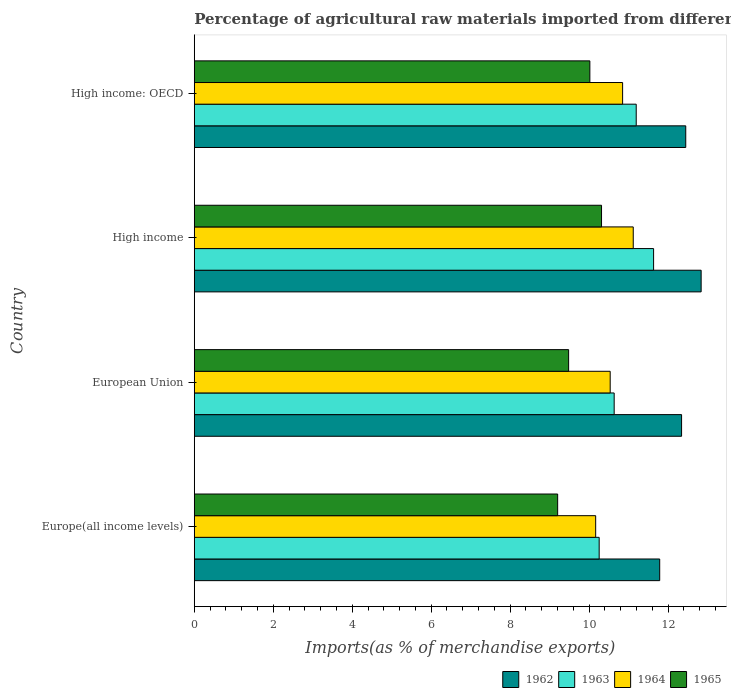How many groups of bars are there?
Provide a succinct answer. 4. Are the number of bars per tick equal to the number of legend labels?
Give a very brief answer. Yes. How many bars are there on the 3rd tick from the top?
Offer a terse response. 4. How many bars are there on the 4th tick from the bottom?
Provide a succinct answer. 4. What is the label of the 4th group of bars from the top?
Provide a succinct answer. Europe(all income levels). In how many cases, is the number of bars for a given country not equal to the number of legend labels?
Provide a succinct answer. 0. What is the percentage of imports to different countries in 1962 in High income?
Offer a terse response. 12.84. Across all countries, what is the maximum percentage of imports to different countries in 1962?
Ensure brevity in your answer.  12.84. Across all countries, what is the minimum percentage of imports to different countries in 1965?
Give a very brief answer. 9.2. In which country was the percentage of imports to different countries in 1964 minimum?
Ensure brevity in your answer.  Europe(all income levels). What is the total percentage of imports to different countries in 1964 in the graph?
Your answer should be very brief. 42.66. What is the difference between the percentage of imports to different countries in 1962 in European Union and that in High income: OECD?
Your answer should be very brief. -0.11. What is the difference between the percentage of imports to different countries in 1965 in High income and the percentage of imports to different countries in 1963 in High income: OECD?
Ensure brevity in your answer.  -0.88. What is the average percentage of imports to different countries in 1963 per country?
Ensure brevity in your answer.  10.93. What is the difference between the percentage of imports to different countries in 1964 and percentage of imports to different countries in 1963 in High income?
Make the answer very short. -0.52. What is the ratio of the percentage of imports to different countries in 1963 in High income to that in High income: OECD?
Keep it short and to the point. 1.04. Is the percentage of imports to different countries in 1963 in European Union less than that in High income: OECD?
Keep it short and to the point. Yes. Is the difference between the percentage of imports to different countries in 1964 in European Union and High income: OECD greater than the difference between the percentage of imports to different countries in 1963 in European Union and High income: OECD?
Your response must be concise. Yes. What is the difference between the highest and the second highest percentage of imports to different countries in 1962?
Provide a succinct answer. 0.39. What is the difference between the highest and the lowest percentage of imports to different countries in 1963?
Make the answer very short. 1.38. In how many countries, is the percentage of imports to different countries in 1965 greater than the average percentage of imports to different countries in 1965 taken over all countries?
Provide a short and direct response. 2. Is the sum of the percentage of imports to different countries in 1965 in European Union and High income: OECD greater than the maximum percentage of imports to different countries in 1962 across all countries?
Your response must be concise. Yes. What does the 3rd bar from the top in High income represents?
Ensure brevity in your answer.  1963. Is it the case that in every country, the sum of the percentage of imports to different countries in 1962 and percentage of imports to different countries in 1963 is greater than the percentage of imports to different countries in 1964?
Provide a short and direct response. Yes. Does the graph contain any zero values?
Your answer should be very brief. No. Does the graph contain grids?
Offer a very short reply. No. How many legend labels are there?
Offer a terse response. 4. What is the title of the graph?
Keep it short and to the point. Percentage of agricultural raw materials imported from different countries. What is the label or title of the X-axis?
Ensure brevity in your answer.  Imports(as % of merchandise exports). What is the label or title of the Y-axis?
Your response must be concise. Country. What is the Imports(as % of merchandise exports) of 1962 in Europe(all income levels)?
Your answer should be compact. 11.79. What is the Imports(as % of merchandise exports) of 1963 in Europe(all income levels)?
Your response must be concise. 10.25. What is the Imports(as % of merchandise exports) of 1964 in Europe(all income levels)?
Keep it short and to the point. 10.17. What is the Imports(as % of merchandise exports) in 1965 in Europe(all income levels)?
Make the answer very short. 9.2. What is the Imports(as % of merchandise exports) of 1962 in European Union?
Keep it short and to the point. 12.34. What is the Imports(as % of merchandise exports) in 1963 in European Union?
Offer a terse response. 10.63. What is the Imports(as % of merchandise exports) of 1964 in European Union?
Your response must be concise. 10.53. What is the Imports(as % of merchandise exports) of 1965 in European Union?
Provide a short and direct response. 9.48. What is the Imports(as % of merchandise exports) in 1962 in High income?
Your response must be concise. 12.84. What is the Imports(as % of merchandise exports) in 1963 in High income?
Provide a short and direct response. 11.63. What is the Imports(as % of merchandise exports) in 1964 in High income?
Provide a succinct answer. 11.12. What is the Imports(as % of merchandise exports) of 1965 in High income?
Offer a terse response. 10.31. What is the Imports(as % of merchandise exports) in 1962 in High income: OECD?
Offer a terse response. 12.45. What is the Imports(as % of merchandise exports) of 1963 in High income: OECD?
Make the answer very short. 11.19. What is the Imports(as % of merchandise exports) in 1964 in High income: OECD?
Your answer should be very brief. 10.85. What is the Imports(as % of merchandise exports) in 1965 in High income: OECD?
Your answer should be compact. 10.02. Across all countries, what is the maximum Imports(as % of merchandise exports) of 1962?
Offer a very short reply. 12.84. Across all countries, what is the maximum Imports(as % of merchandise exports) in 1963?
Ensure brevity in your answer.  11.63. Across all countries, what is the maximum Imports(as % of merchandise exports) of 1964?
Offer a terse response. 11.12. Across all countries, what is the maximum Imports(as % of merchandise exports) in 1965?
Your response must be concise. 10.31. Across all countries, what is the minimum Imports(as % of merchandise exports) of 1962?
Keep it short and to the point. 11.79. Across all countries, what is the minimum Imports(as % of merchandise exports) in 1963?
Keep it short and to the point. 10.25. Across all countries, what is the minimum Imports(as % of merchandise exports) in 1964?
Provide a short and direct response. 10.17. Across all countries, what is the minimum Imports(as % of merchandise exports) in 1965?
Offer a very short reply. 9.2. What is the total Imports(as % of merchandise exports) of 1962 in the graph?
Provide a short and direct response. 49.41. What is the total Imports(as % of merchandise exports) of 1963 in the graph?
Your answer should be very brief. 43.71. What is the total Imports(as % of merchandise exports) in 1964 in the graph?
Provide a short and direct response. 42.66. What is the total Imports(as % of merchandise exports) of 1965 in the graph?
Offer a very short reply. 39.01. What is the difference between the Imports(as % of merchandise exports) in 1962 in Europe(all income levels) and that in European Union?
Provide a short and direct response. -0.55. What is the difference between the Imports(as % of merchandise exports) of 1963 in Europe(all income levels) and that in European Union?
Keep it short and to the point. -0.38. What is the difference between the Imports(as % of merchandise exports) in 1964 in Europe(all income levels) and that in European Union?
Keep it short and to the point. -0.37. What is the difference between the Imports(as % of merchandise exports) of 1965 in Europe(all income levels) and that in European Union?
Your answer should be very brief. -0.28. What is the difference between the Imports(as % of merchandise exports) in 1962 in Europe(all income levels) and that in High income?
Your answer should be compact. -1.05. What is the difference between the Imports(as % of merchandise exports) of 1963 in Europe(all income levels) and that in High income?
Keep it short and to the point. -1.38. What is the difference between the Imports(as % of merchandise exports) of 1964 in Europe(all income levels) and that in High income?
Give a very brief answer. -0.95. What is the difference between the Imports(as % of merchandise exports) of 1965 in Europe(all income levels) and that in High income?
Give a very brief answer. -1.11. What is the difference between the Imports(as % of merchandise exports) of 1962 in Europe(all income levels) and that in High income: OECD?
Provide a short and direct response. -0.66. What is the difference between the Imports(as % of merchandise exports) in 1963 in Europe(all income levels) and that in High income: OECD?
Offer a terse response. -0.94. What is the difference between the Imports(as % of merchandise exports) in 1964 in Europe(all income levels) and that in High income: OECD?
Keep it short and to the point. -0.68. What is the difference between the Imports(as % of merchandise exports) in 1965 in Europe(all income levels) and that in High income: OECD?
Provide a succinct answer. -0.82. What is the difference between the Imports(as % of merchandise exports) in 1962 in European Union and that in High income?
Keep it short and to the point. -0.5. What is the difference between the Imports(as % of merchandise exports) in 1963 in European Union and that in High income?
Provide a short and direct response. -1. What is the difference between the Imports(as % of merchandise exports) of 1964 in European Union and that in High income?
Provide a succinct answer. -0.58. What is the difference between the Imports(as % of merchandise exports) of 1965 in European Union and that in High income?
Provide a short and direct response. -0.83. What is the difference between the Imports(as % of merchandise exports) of 1962 in European Union and that in High income: OECD?
Offer a terse response. -0.11. What is the difference between the Imports(as % of merchandise exports) of 1963 in European Union and that in High income: OECD?
Your answer should be very brief. -0.56. What is the difference between the Imports(as % of merchandise exports) in 1964 in European Union and that in High income: OECD?
Offer a very short reply. -0.31. What is the difference between the Imports(as % of merchandise exports) of 1965 in European Union and that in High income: OECD?
Your answer should be very brief. -0.54. What is the difference between the Imports(as % of merchandise exports) in 1962 in High income and that in High income: OECD?
Give a very brief answer. 0.39. What is the difference between the Imports(as % of merchandise exports) of 1963 in High income and that in High income: OECD?
Provide a short and direct response. 0.44. What is the difference between the Imports(as % of merchandise exports) in 1964 in High income and that in High income: OECD?
Your response must be concise. 0.27. What is the difference between the Imports(as % of merchandise exports) in 1965 in High income and that in High income: OECD?
Keep it short and to the point. 0.3. What is the difference between the Imports(as % of merchandise exports) of 1962 in Europe(all income levels) and the Imports(as % of merchandise exports) of 1963 in European Union?
Ensure brevity in your answer.  1.15. What is the difference between the Imports(as % of merchandise exports) in 1962 in Europe(all income levels) and the Imports(as % of merchandise exports) in 1964 in European Union?
Give a very brief answer. 1.25. What is the difference between the Imports(as % of merchandise exports) in 1962 in Europe(all income levels) and the Imports(as % of merchandise exports) in 1965 in European Union?
Make the answer very short. 2.31. What is the difference between the Imports(as % of merchandise exports) of 1963 in Europe(all income levels) and the Imports(as % of merchandise exports) of 1964 in European Union?
Provide a short and direct response. -0.28. What is the difference between the Imports(as % of merchandise exports) of 1963 in Europe(all income levels) and the Imports(as % of merchandise exports) of 1965 in European Union?
Your response must be concise. 0.77. What is the difference between the Imports(as % of merchandise exports) of 1964 in Europe(all income levels) and the Imports(as % of merchandise exports) of 1965 in European Union?
Make the answer very short. 0.68. What is the difference between the Imports(as % of merchandise exports) of 1962 in Europe(all income levels) and the Imports(as % of merchandise exports) of 1963 in High income?
Ensure brevity in your answer.  0.15. What is the difference between the Imports(as % of merchandise exports) in 1962 in Europe(all income levels) and the Imports(as % of merchandise exports) in 1964 in High income?
Give a very brief answer. 0.67. What is the difference between the Imports(as % of merchandise exports) in 1962 in Europe(all income levels) and the Imports(as % of merchandise exports) in 1965 in High income?
Your answer should be compact. 1.47. What is the difference between the Imports(as % of merchandise exports) of 1963 in Europe(all income levels) and the Imports(as % of merchandise exports) of 1964 in High income?
Offer a terse response. -0.86. What is the difference between the Imports(as % of merchandise exports) of 1963 in Europe(all income levels) and the Imports(as % of merchandise exports) of 1965 in High income?
Make the answer very short. -0.06. What is the difference between the Imports(as % of merchandise exports) of 1964 in Europe(all income levels) and the Imports(as % of merchandise exports) of 1965 in High income?
Offer a very short reply. -0.15. What is the difference between the Imports(as % of merchandise exports) in 1962 in Europe(all income levels) and the Imports(as % of merchandise exports) in 1963 in High income: OECD?
Your response must be concise. 0.59. What is the difference between the Imports(as % of merchandise exports) of 1962 in Europe(all income levels) and the Imports(as % of merchandise exports) of 1964 in High income: OECD?
Offer a very short reply. 0.94. What is the difference between the Imports(as % of merchandise exports) in 1962 in Europe(all income levels) and the Imports(as % of merchandise exports) in 1965 in High income: OECD?
Your answer should be very brief. 1.77. What is the difference between the Imports(as % of merchandise exports) of 1963 in Europe(all income levels) and the Imports(as % of merchandise exports) of 1964 in High income: OECD?
Provide a succinct answer. -0.59. What is the difference between the Imports(as % of merchandise exports) in 1963 in Europe(all income levels) and the Imports(as % of merchandise exports) in 1965 in High income: OECD?
Provide a short and direct response. 0.24. What is the difference between the Imports(as % of merchandise exports) in 1964 in Europe(all income levels) and the Imports(as % of merchandise exports) in 1965 in High income: OECD?
Provide a succinct answer. 0.15. What is the difference between the Imports(as % of merchandise exports) in 1962 in European Union and the Imports(as % of merchandise exports) in 1963 in High income?
Keep it short and to the point. 0.71. What is the difference between the Imports(as % of merchandise exports) in 1962 in European Union and the Imports(as % of merchandise exports) in 1964 in High income?
Provide a short and direct response. 1.22. What is the difference between the Imports(as % of merchandise exports) in 1962 in European Union and the Imports(as % of merchandise exports) in 1965 in High income?
Offer a terse response. 2.03. What is the difference between the Imports(as % of merchandise exports) in 1963 in European Union and the Imports(as % of merchandise exports) in 1964 in High income?
Offer a very short reply. -0.48. What is the difference between the Imports(as % of merchandise exports) of 1963 in European Union and the Imports(as % of merchandise exports) of 1965 in High income?
Provide a short and direct response. 0.32. What is the difference between the Imports(as % of merchandise exports) of 1964 in European Union and the Imports(as % of merchandise exports) of 1965 in High income?
Make the answer very short. 0.22. What is the difference between the Imports(as % of merchandise exports) of 1962 in European Union and the Imports(as % of merchandise exports) of 1963 in High income: OECD?
Provide a succinct answer. 1.15. What is the difference between the Imports(as % of merchandise exports) of 1962 in European Union and the Imports(as % of merchandise exports) of 1964 in High income: OECD?
Your answer should be very brief. 1.49. What is the difference between the Imports(as % of merchandise exports) in 1962 in European Union and the Imports(as % of merchandise exports) in 1965 in High income: OECD?
Keep it short and to the point. 2.32. What is the difference between the Imports(as % of merchandise exports) in 1963 in European Union and the Imports(as % of merchandise exports) in 1964 in High income: OECD?
Provide a short and direct response. -0.21. What is the difference between the Imports(as % of merchandise exports) of 1963 in European Union and the Imports(as % of merchandise exports) of 1965 in High income: OECD?
Ensure brevity in your answer.  0.62. What is the difference between the Imports(as % of merchandise exports) in 1964 in European Union and the Imports(as % of merchandise exports) in 1965 in High income: OECD?
Provide a succinct answer. 0.51. What is the difference between the Imports(as % of merchandise exports) in 1962 in High income and the Imports(as % of merchandise exports) in 1963 in High income: OECD?
Your response must be concise. 1.64. What is the difference between the Imports(as % of merchandise exports) of 1962 in High income and the Imports(as % of merchandise exports) of 1964 in High income: OECD?
Keep it short and to the point. 1.99. What is the difference between the Imports(as % of merchandise exports) in 1962 in High income and the Imports(as % of merchandise exports) in 1965 in High income: OECD?
Ensure brevity in your answer.  2.82. What is the difference between the Imports(as % of merchandise exports) in 1963 in High income and the Imports(as % of merchandise exports) in 1964 in High income: OECD?
Your response must be concise. 0.78. What is the difference between the Imports(as % of merchandise exports) of 1963 in High income and the Imports(as % of merchandise exports) of 1965 in High income: OECD?
Give a very brief answer. 1.61. What is the difference between the Imports(as % of merchandise exports) of 1964 in High income and the Imports(as % of merchandise exports) of 1965 in High income: OECD?
Provide a succinct answer. 1.1. What is the average Imports(as % of merchandise exports) in 1962 per country?
Your answer should be compact. 12.35. What is the average Imports(as % of merchandise exports) in 1963 per country?
Make the answer very short. 10.93. What is the average Imports(as % of merchandise exports) in 1964 per country?
Your answer should be very brief. 10.67. What is the average Imports(as % of merchandise exports) of 1965 per country?
Offer a terse response. 9.75. What is the difference between the Imports(as % of merchandise exports) of 1962 and Imports(as % of merchandise exports) of 1963 in Europe(all income levels)?
Your response must be concise. 1.53. What is the difference between the Imports(as % of merchandise exports) of 1962 and Imports(as % of merchandise exports) of 1964 in Europe(all income levels)?
Your answer should be compact. 1.62. What is the difference between the Imports(as % of merchandise exports) in 1962 and Imports(as % of merchandise exports) in 1965 in Europe(all income levels)?
Provide a short and direct response. 2.58. What is the difference between the Imports(as % of merchandise exports) in 1963 and Imports(as % of merchandise exports) in 1964 in Europe(all income levels)?
Make the answer very short. 0.09. What is the difference between the Imports(as % of merchandise exports) of 1963 and Imports(as % of merchandise exports) of 1965 in Europe(all income levels)?
Your response must be concise. 1.05. What is the difference between the Imports(as % of merchandise exports) of 1964 and Imports(as % of merchandise exports) of 1965 in Europe(all income levels)?
Give a very brief answer. 0.96. What is the difference between the Imports(as % of merchandise exports) in 1962 and Imports(as % of merchandise exports) in 1963 in European Union?
Offer a very short reply. 1.71. What is the difference between the Imports(as % of merchandise exports) of 1962 and Imports(as % of merchandise exports) of 1964 in European Union?
Your answer should be compact. 1.81. What is the difference between the Imports(as % of merchandise exports) of 1962 and Imports(as % of merchandise exports) of 1965 in European Union?
Provide a short and direct response. 2.86. What is the difference between the Imports(as % of merchandise exports) of 1963 and Imports(as % of merchandise exports) of 1964 in European Union?
Your answer should be very brief. 0.1. What is the difference between the Imports(as % of merchandise exports) in 1963 and Imports(as % of merchandise exports) in 1965 in European Union?
Your answer should be compact. 1.15. What is the difference between the Imports(as % of merchandise exports) in 1964 and Imports(as % of merchandise exports) in 1965 in European Union?
Offer a very short reply. 1.05. What is the difference between the Imports(as % of merchandise exports) in 1962 and Imports(as % of merchandise exports) in 1963 in High income?
Your answer should be very brief. 1.2. What is the difference between the Imports(as % of merchandise exports) in 1962 and Imports(as % of merchandise exports) in 1964 in High income?
Provide a short and direct response. 1.72. What is the difference between the Imports(as % of merchandise exports) in 1962 and Imports(as % of merchandise exports) in 1965 in High income?
Your answer should be very brief. 2.52. What is the difference between the Imports(as % of merchandise exports) of 1963 and Imports(as % of merchandise exports) of 1964 in High income?
Your response must be concise. 0.52. What is the difference between the Imports(as % of merchandise exports) of 1963 and Imports(as % of merchandise exports) of 1965 in High income?
Offer a terse response. 1.32. What is the difference between the Imports(as % of merchandise exports) in 1964 and Imports(as % of merchandise exports) in 1965 in High income?
Your answer should be very brief. 0.8. What is the difference between the Imports(as % of merchandise exports) of 1962 and Imports(as % of merchandise exports) of 1963 in High income: OECD?
Your answer should be very brief. 1.25. What is the difference between the Imports(as % of merchandise exports) of 1962 and Imports(as % of merchandise exports) of 1964 in High income: OECD?
Give a very brief answer. 1.6. What is the difference between the Imports(as % of merchandise exports) in 1962 and Imports(as % of merchandise exports) in 1965 in High income: OECD?
Make the answer very short. 2.43. What is the difference between the Imports(as % of merchandise exports) of 1963 and Imports(as % of merchandise exports) of 1964 in High income: OECD?
Your answer should be compact. 0.34. What is the difference between the Imports(as % of merchandise exports) in 1963 and Imports(as % of merchandise exports) in 1965 in High income: OECD?
Ensure brevity in your answer.  1.17. What is the difference between the Imports(as % of merchandise exports) of 1964 and Imports(as % of merchandise exports) of 1965 in High income: OECD?
Offer a very short reply. 0.83. What is the ratio of the Imports(as % of merchandise exports) of 1962 in Europe(all income levels) to that in European Union?
Your answer should be compact. 0.96. What is the ratio of the Imports(as % of merchandise exports) of 1963 in Europe(all income levels) to that in European Union?
Keep it short and to the point. 0.96. What is the ratio of the Imports(as % of merchandise exports) of 1964 in Europe(all income levels) to that in European Union?
Provide a short and direct response. 0.97. What is the ratio of the Imports(as % of merchandise exports) in 1965 in Europe(all income levels) to that in European Union?
Give a very brief answer. 0.97. What is the ratio of the Imports(as % of merchandise exports) in 1962 in Europe(all income levels) to that in High income?
Give a very brief answer. 0.92. What is the ratio of the Imports(as % of merchandise exports) in 1963 in Europe(all income levels) to that in High income?
Keep it short and to the point. 0.88. What is the ratio of the Imports(as % of merchandise exports) in 1964 in Europe(all income levels) to that in High income?
Provide a short and direct response. 0.91. What is the ratio of the Imports(as % of merchandise exports) of 1965 in Europe(all income levels) to that in High income?
Your response must be concise. 0.89. What is the ratio of the Imports(as % of merchandise exports) in 1962 in Europe(all income levels) to that in High income: OECD?
Give a very brief answer. 0.95. What is the ratio of the Imports(as % of merchandise exports) of 1963 in Europe(all income levels) to that in High income: OECD?
Give a very brief answer. 0.92. What is the ratio of the Imports(as % of merchandise exports) of 1964 in Europe(all income levels) to that in High income: OECD?
Your response must be concise. 0.94. What is the ratio of the Imports(as % of merchandise exports) in 1965 in Europe(all income levels) to that in High income: OECD?
Offer a very short reply. 0.92. What is the ratio of the Imports(as % of merchandise exports) in 1962 in European Union to that in High income?
Provide a succinct answer. 0.96. What is the ratio of the Imports(as % of merchandise exports) in 1963 in European Union to that in High income?
Offer a very short reply. 0.91. What is the ratio of the Imports(as % of merchandise exports) in 1964 in European Union to that in High income?
Offer a terse response. 0.95. What is the ratio of the Imports(as % of merchandise exports) of 1965 in European Union to that in High income?
Give a very brief answer. 0.92. What is the ratio of the Imports(as % of merchandise exports) of 1963 in European Union to that in High income: OECD?
Offer a very short reply. 0.95. What is the ratio of the Imports(as % of merchandise exports) in 1965 in European Union to that in High income: OECD?
Offer a very short reply. 0.95. What is the ratio of the Imports(as % of merchandise exports) in 1962 in High income to that in High income: OECD?
Give a very brief answer. 1.03. What is the ratio of the Imports(as % of merchandise exports) in 1963 in High income to that in High income: OECD?
Ensure brevity in your answer.  1.04. What is the ratio of the Imports(as % of merchandise exports) of 1964 in High income to that in High income: OECD?
Give a very brief answer. 1.02. What is the ratio of the Imports(as % of merchandise exports) in 1965 in High income to that in High income: OECD?
Your answer should be very brief. 1.03. What is the difference between the highest and the second highest Imports(as % of merchandise exports) in 1962?
Your response must be concise. 0.39. What is the difference between the highest and the second highest Imports(as % of merchandise exports) of 1963?
Provide a succinct answer. 0.44. What is the difference between the highest and the second highest Imports(as % of merchandise exports) of 1964?
Offer a very short reply. 0.27. What is the difference between the highest and the second highest Imports(as % of merchandise exports) in 1965?
Provide a short and direct response. 0.3. What is the difference between the highest and the lowest Imports(as % of merchandise exports) in 1962?
Offer a terse response. 1.05. What is the difference between the highest and the lowest Imports(as % of merchandise exports) in 1963?
Provide a succinct answer. 1.38. What is the difference between the highest and the lowest Imports(as % of merchandise exports) of 1964?
Your answer should be very brief. 0.95. What is the difference between the highest and the lowest Imports(as % of merchandise exports) in 1965?
Give a very brief answer. 1.11. 